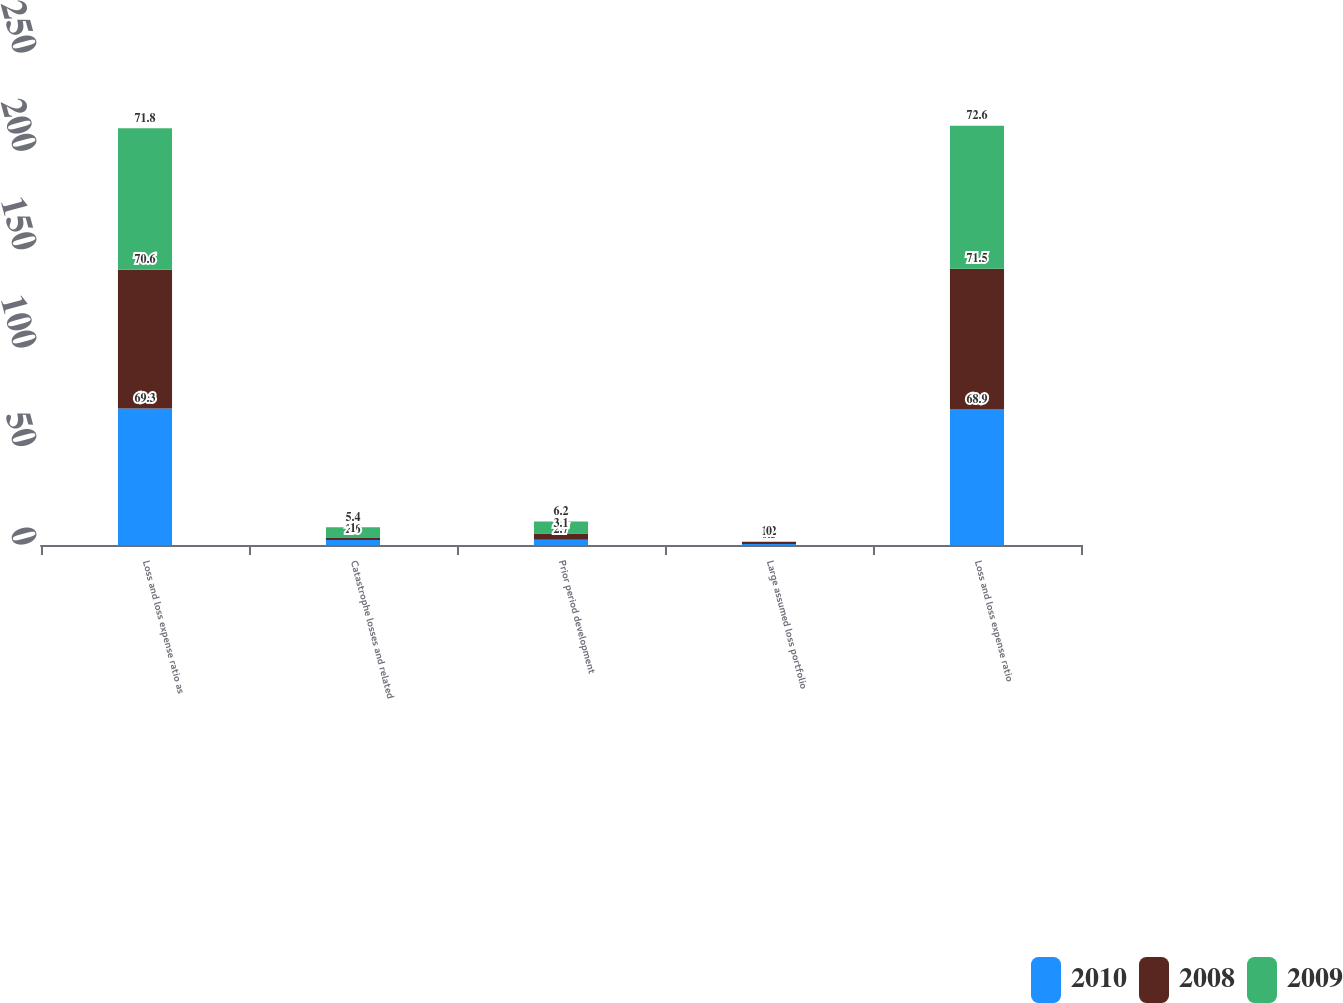<chart> <loc_0><loc_0><loc_500><loc_500><stacked_bar_chart><ecel><fcel>Loss and loss expense ratio as<fcel>Catastrophe losses and related<fcel>Prior period development<fcel>Large assumed loss portfolio<fcel>Loss and loss expense ratio<nl><fcel>2010<fcel>69.3<fcel>2.6<fcel>2.7<fcel>0.5<fcel>68.9<nl><fcel>2008<fcel>70.6<fcel>1<fcel>3.1<fcel>1.2<fcel>71.5<nl><fcel>2009<fcel>71.8<fcel>5.4<fcel>6.2<fcel>0<fcel>72.6<nl></chart> 